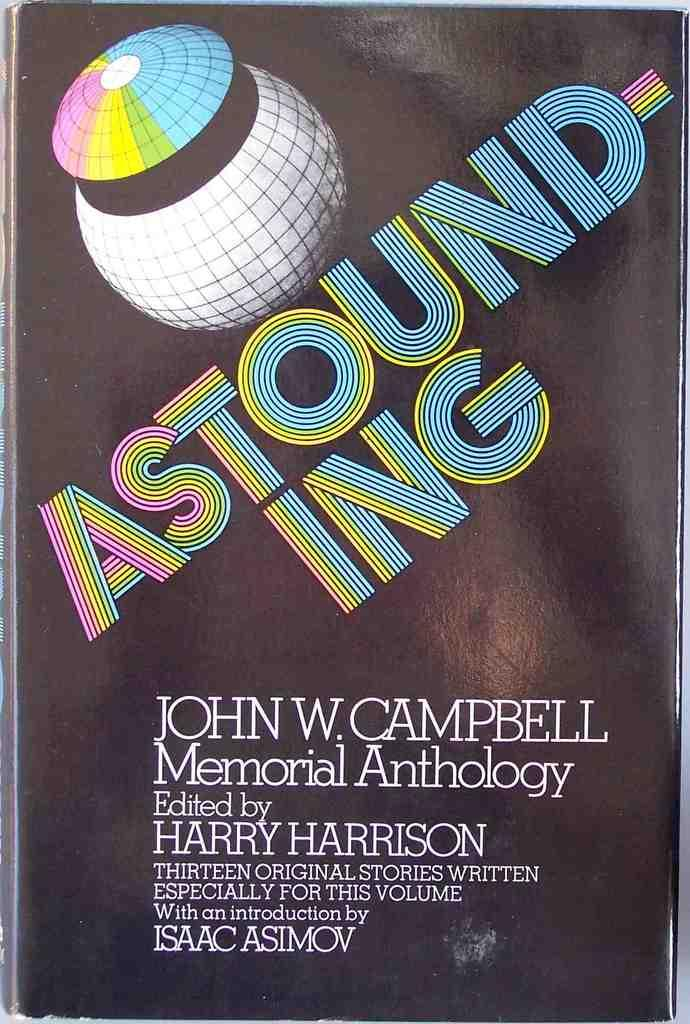What is the main subject of the image? The main subject of the image is the cover page of a book. What can be seen on the cover page? There is an image and writing on the cover page. How many teeth are visible on the cover page of the book in the image? There are no teeth visible on the cover page of the book in the image. 